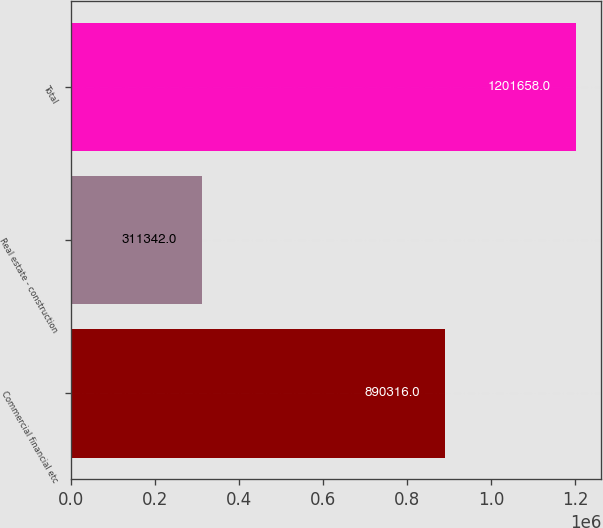Convert chart. <chart><loc_0><loc_0><loc_500><loc_500><bar_chart><fcel>Commercial financial etc<fcel>Real estate - construction<fcel>Total<nl><fcel>890316<fcel>311342<fcel>1.20166e+06<nl></chart> 